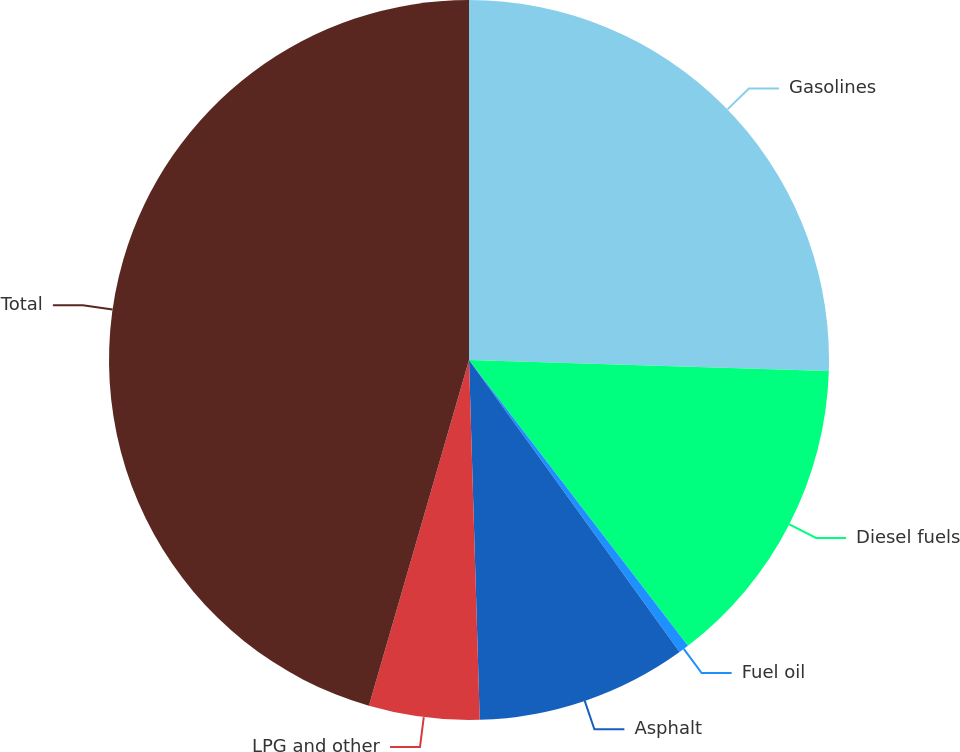<chart> <loc_0><loc_0><loc_500><loc_500><pie_chart><fcel>Gasolines<fcel>Diesel fuels<fcel>Fuel oil<fcel>Asphalt<fcel>LPG and other<fcel>Total<nl><fcel>25.49%<fcel>14.11%<fcel>0.46%<fcel>9.47%<fcel>4.96%<fcel>45.52%<nl></chart> 